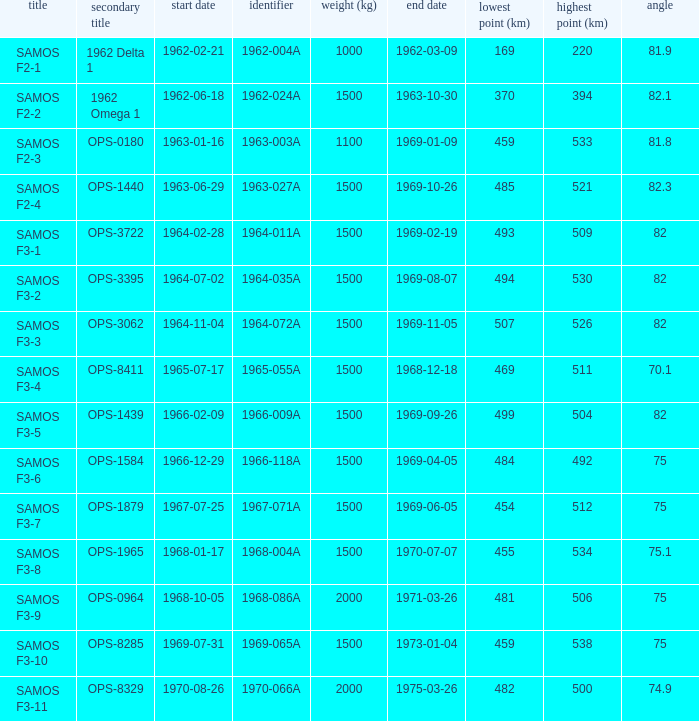What is the inclination when the alt name is OPS-1584? 75.0. 